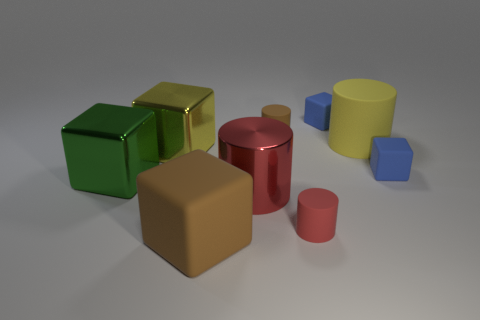Subtract 1 cylinders. How many cylinders are left? 3 Subtract all brown cubes. How many cubes are left? 4 Subtract all yellow metal blocks. How many blocks are left? 4 Subtract all cyan cubes. Subtract all gray cylinders. How many cubes are left? 5 Add 1 big yellow things. How many objects exist? 10 Subtract all cylinders. How many objects are left? 5 Add 2 brown things. How many brown things exist? 4 Subtract 0 yellow spheres. How many objects are left? 9 Subtract all purple objects. Subtract all small brown things. How many objects are left? 8 Add 2 green metallic cubes. How many green metallic cubes are left? 3 